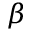Convert formula to latex. <formula><loc_0><loc_0><loc_500><loc_500>\beta</formula> 